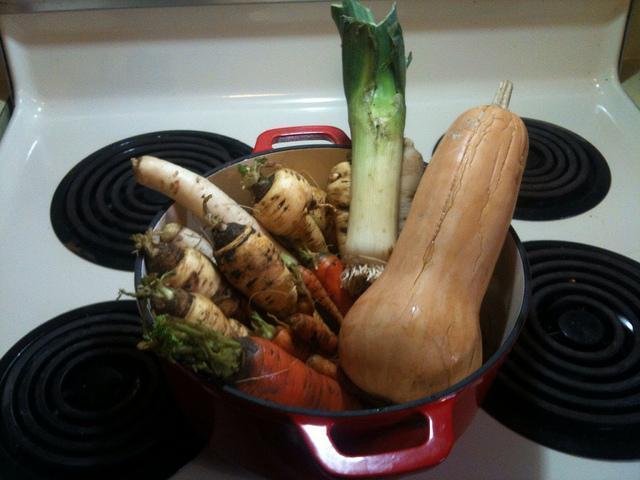How many donuts have chocolate on them?
Give a very brief answer. 0. 